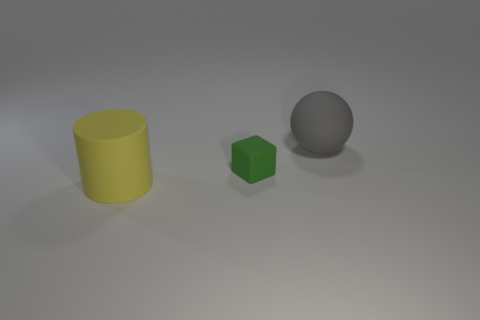Add 1 large things. How many objects exist? 4 Subtract all blocks. How many objects are left? 2 Subtract 0 brown balls. How many objects are left? 3 Subtract all large rubber cylinders. Subtract all large green rubber cylinders. How many objects are left? 2 Add 1 large things. How many large things are left? 3 Add 2 small cubes. How many small cubes exist? 3 